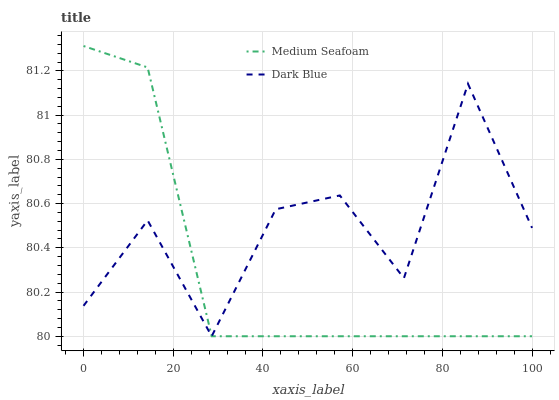Does Medium Seafoam have the minimum area under the curve?
Answer yes or no. Yes. Does Dark Blue have the maximum area under the curve?
Answer yes or no. Yes. Does Medium Seafoam have the maximum area under the curve?
Answer yes or no. No. Is Medium Seafoam the smoothest?
Answer yes or no. Yes. Is Dark Blue the roughest?
Answer yes or no. Yes. Is Medium Seafoam the roughest?
Answer yes or no. No. Does Dark Blue have the lowest value?
Answer yes or no. Yes. Does Medium Seafoam have the highest value?
Answer yes or no. Yes. Does Dark Blue intersect Medium Seafoam?
Answer yes or no. Yes. Is Dark Blue less than Medium Seafoam?
Answer yes or no. No. Is Dark Blue greater than Medium Seafoam?
Answer yes or no. No. 